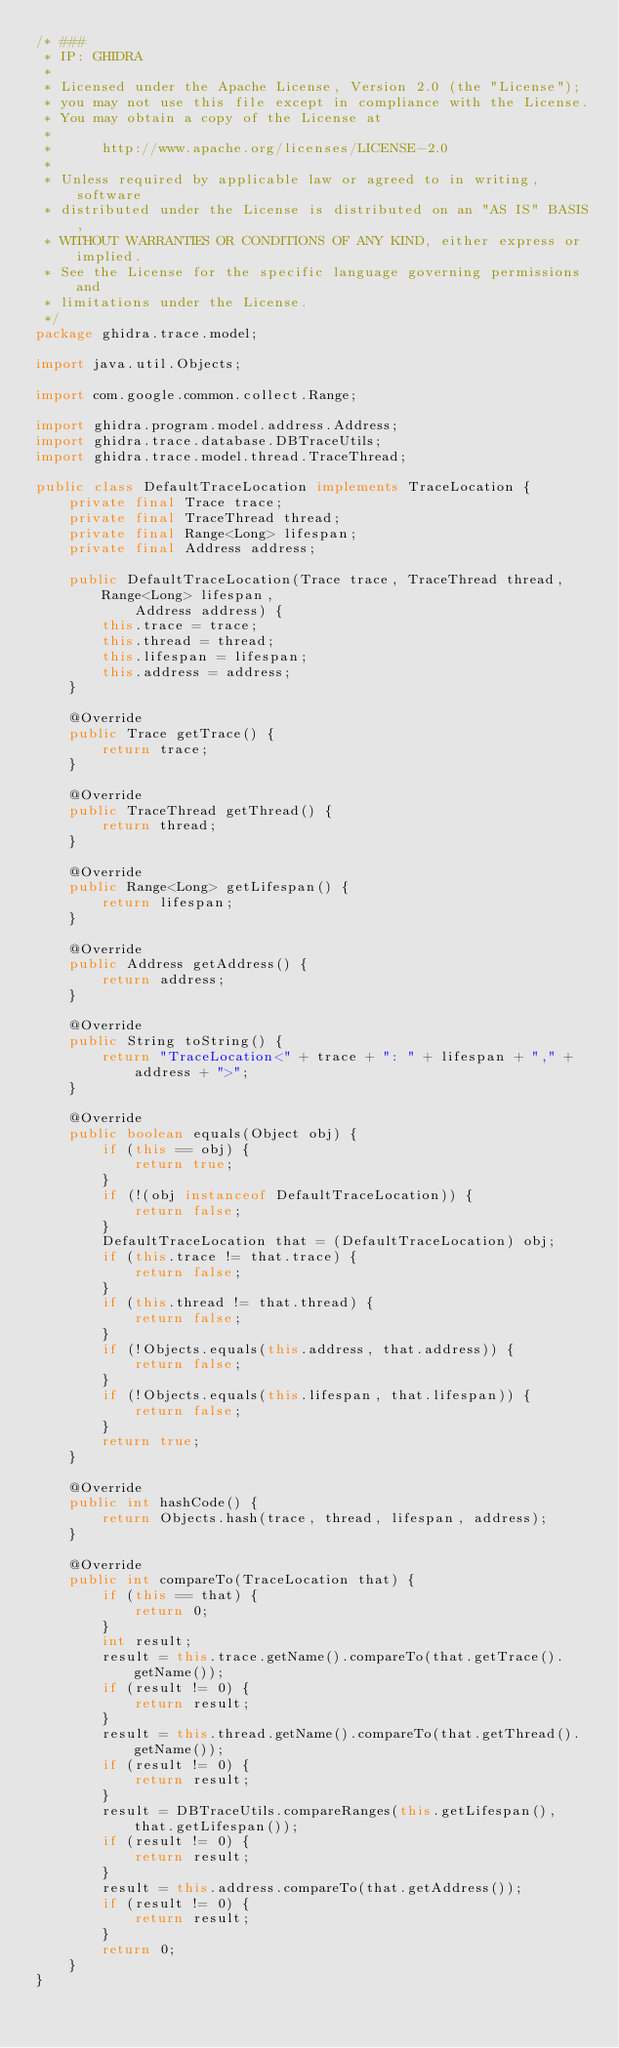Convert code to text. <code><loc_0><loc_0><loc_500><loc_500><_Java_>/* ###
 * IP: GHIDRA
 *
 * Licensed under the Apache License, Version 2.0 (the "License");
 * you may not use this file except in compliance with the License.
 * You may obtain a copy of the License at
 * 
 *      http://www.apache.org/licenses/LICENSE-2.0
 * 
 * Unless required by applicable law or agreed to in writing, software
 * distributed under the License is distributed on an "AS IS" BASIS,
 * WITHOUT WARRANTIES OR CONDITIONS OF ANY KIND, either express or implied.
 * See the License for the specific language governing permissions and
 * limitations under the License.
 */
package ghidra.trace.model;

import java.util.Objects;

import com.google.common.collect.Range;

import ghidra.program.model.address.Address;
import ghidra.trace.database.DBTraceUtils;
import ghidra.trace.model.thread.TraceThread;

public class DefaultTraceLocation implements TraceLocation {
	private final Trace trace;
	private final TraceThread thread;
	private final Range<Long> lifespan;
	private final Address address;

	public DefaultTraceLocation(Trace trace, TraceThread thread, Range<Long> lifespan,
			Address address) {
		this.trace = trace;
		this.thread = thread;
		this.lifespan = lifespan;
		this.address = address;
	}

	@Override
	public Trace getTrace() {
		return trace;
	}

	@Override
	public TraceThread getThread() {
		return thread;
	}

	@Override
	public Range<Long> getLifespan() {
		return lifespan;
	}

	@Override
	public Address getAddress() {
		return address;
	}

	@Override
	public String toString() {
		return "TraceLocation<" + trace + ": " + lifespan + "," + address + ">";
	}

	@Override
	public boolean equals(Object obj) {
		if (this == obj) {
			return true;
		}
		if (!(obj instanceof DefaultTraceLocation)) {
			return false;
		}
		DefaultTraceLocation that = (DefaultTraceLocation) obj;
		if (this.trace != that.trace) {
			return false;
		}
		if (this.thread != that.thread) {
			return false;
		}
		if (!Objects.equals(this.address, that.address)) {
			return false;
		}
		if (!Objects.equals(this.lifespan, that.lifespan)) {
			return false;
		}
		return true;
	}

	@Override
	public int hashCode() {
		return Objects.hash(trace, thread, lifespan, address);
	}

	@Override
	public int compareTo(TraceLocation that) {
		if (this == that) {
			return 0;
		}
		int result;
		result = this.trace.getName().compareTo(that.getTrace().getName());
		if (result != 0) {
			return result;
		}
		result = this.thread.getName().compareTo(that.getThread().getName());
		if (result != 0) {
			return result;
		}
		result = DBTraceUtils.compareRanges(this.getLifespan(), that.getLifespan());
		if (result != 0) {
			return result;
		}
		result = this.address.compareTo(that.getAddress());
		if (result != 0) {
			return result;
		}
		return 0;
	}
}
</code> 